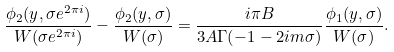<formula> <loc_0><loc_0><loc_500><loc_500>\frac { \phi _ { 2 } ( y , \sigma e ^ { 2 \pi i } ) } { W ( \sigma e ^ { 2 \pi i } ) } - \frac { \phi _ { 2 } ( y , \sigma ) } { W ( \sigma ) } = \frac { i \pi B } { 3 A \Gamma ( - 1 - 2 i m \sigma ) } \frac { \phi _ { 1 } ( y , \sigma ) } { W ( \sigma ) } .</formula> 